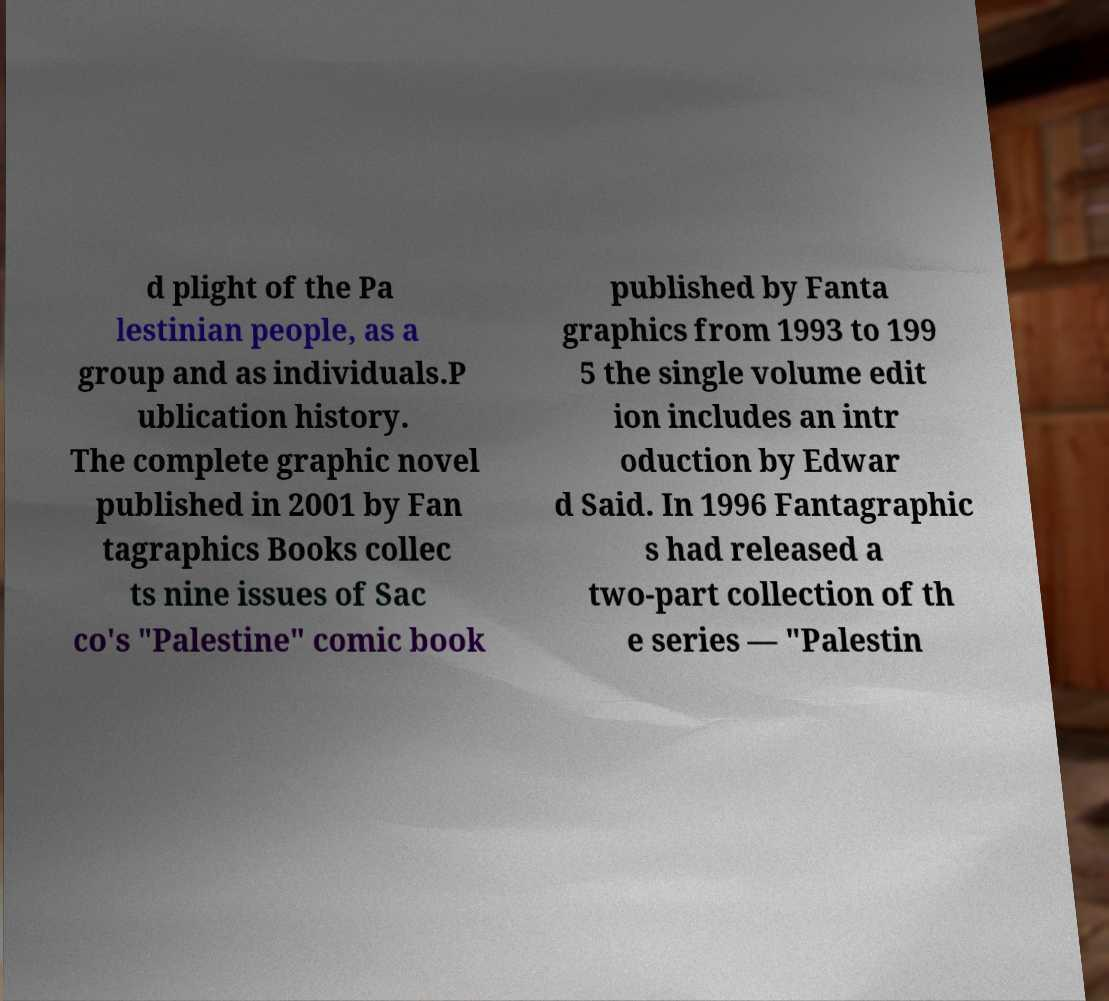Could you extract and type out the text from this image? d plight of the Pa lestinian people, as a group and as individuals.P ublication history. The complete graphic novel published in 2001 by Fan tagraphics Books collec ts nine issues of Sac co's "Palestine" comic book published by Fanta graphics from 1993 to 199 5 the single volume edit ion includes an intr oduction by Edwar d Said. In 1996 Fantagraphic s had released a two-part collection of th e series — "Palestin 